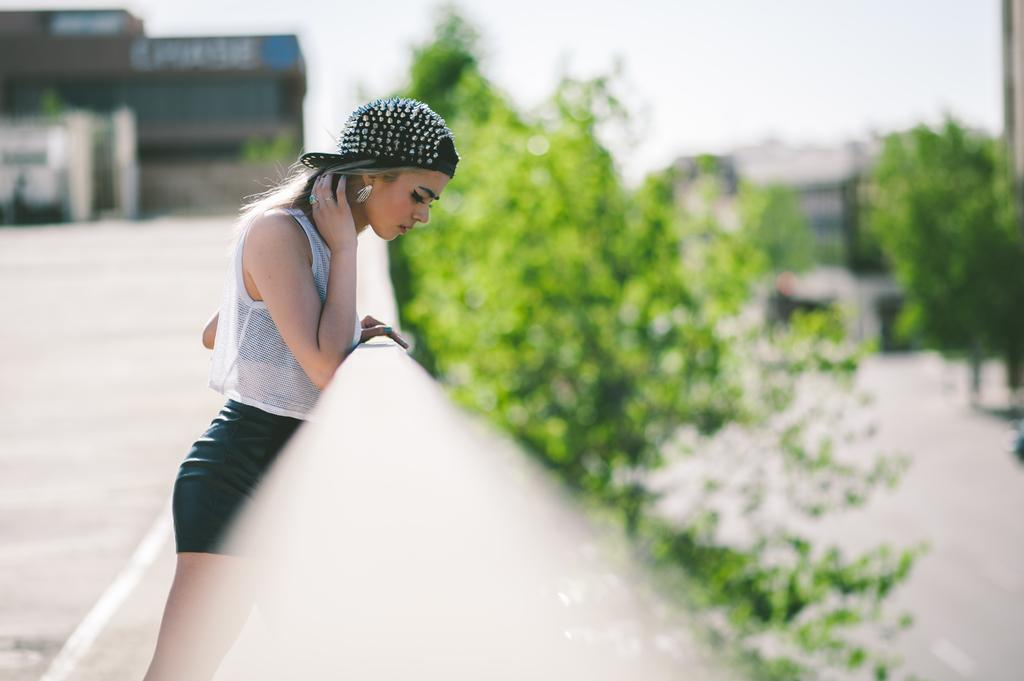Who or what is present in the image? There is a person in the image. What type of structures can be seen in the image? There are buildings in the image. What type of vegetation is present in the image? There are trees in the image. Can you describe the background of the image? The background of the image is blurred. How many tomatoes are hanging from the person's ear in the image? There are no tomatoes present in the image, and therefore none are hanging from the person's ear. 